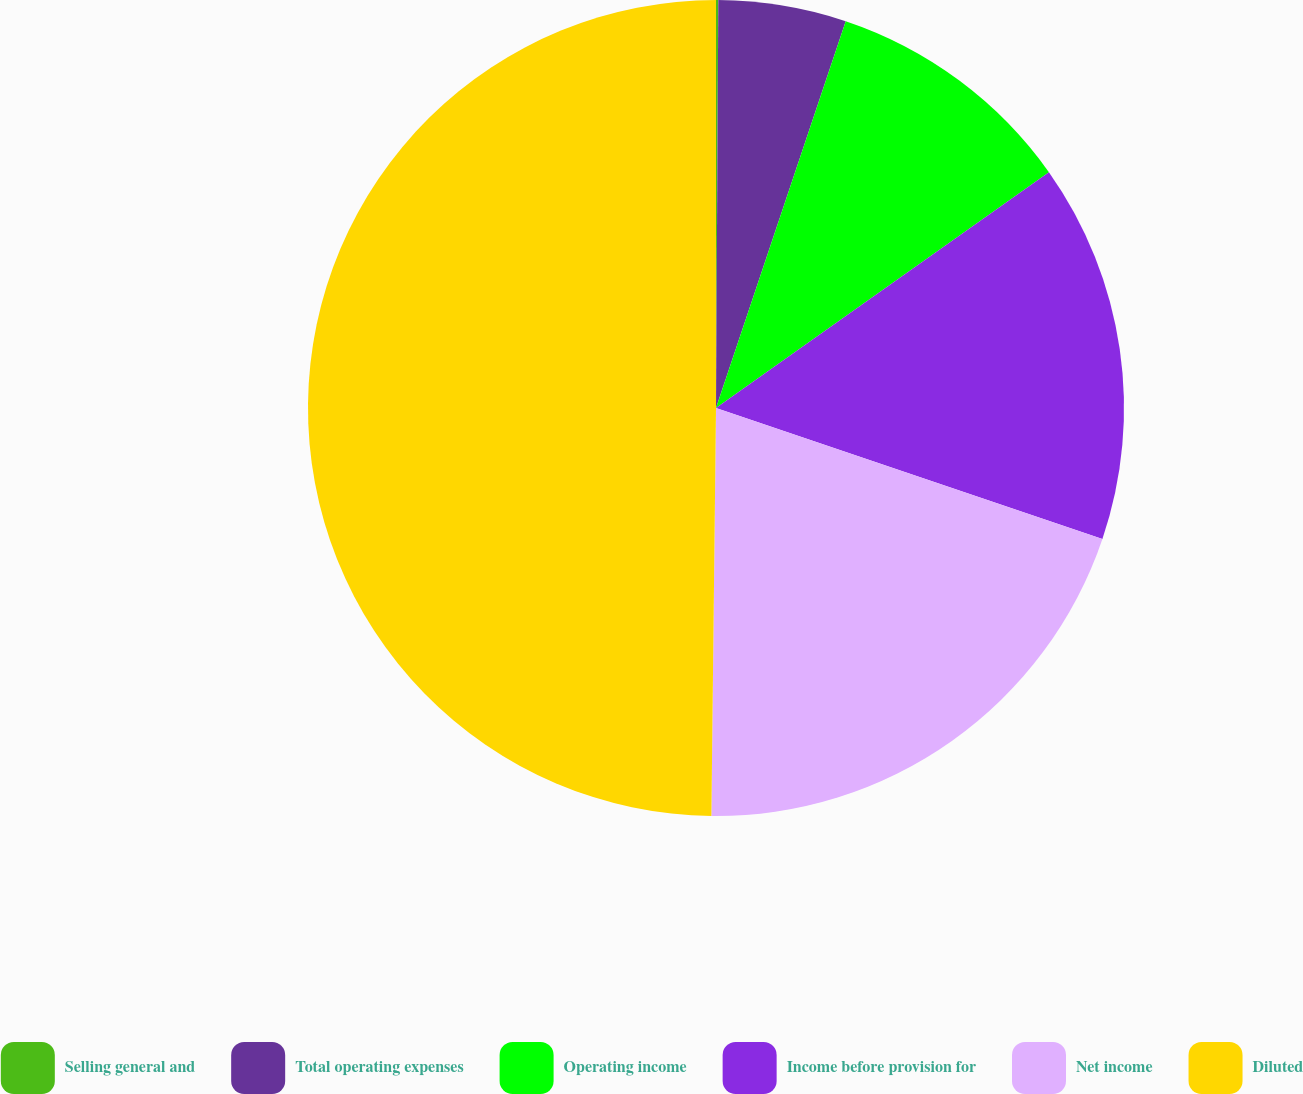Convert chart to OTSL. <chart><loc_0><loc_0><loc_500><loc_500><pie_chart><fcel>Selling general and<fcel>Total operating expenses<fcel>Operating income<fcel>Income before provision for<fcel>Net income<fcel>Diluted<nl><fcel>0.09%<fcel>5.06%<fcel>10.04%<fcel>15.01%<fcel>19.98%<fcel>49.82%<nl></chart> 